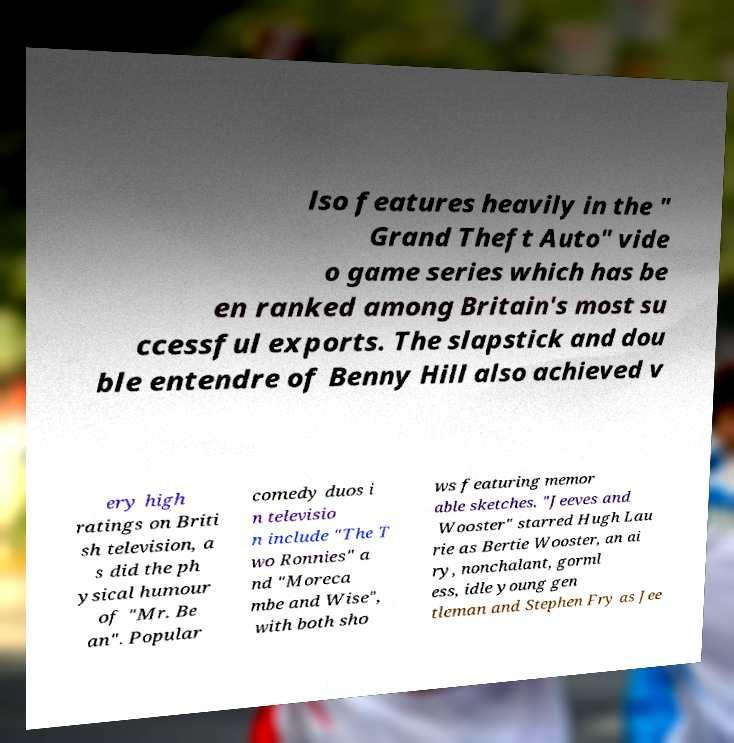For documentation purposes, I need the text within this image transcribed. Could you provide that? lso features heavily in the " Grand Theft Auto" vide o game series which has be en ranked among Britain's most su ccessful exports. The slapstick and dou ble entendre of Benny Hill also achieved v ery high ratings on Briti sh television, a s did the ph ysical humour of "Mr. Be an". Popular comedy duos i n televisio n include "The T wo Ronnies" a nd "Moreca mbe and Wise", with both sho ws featuring memor able sketches. "Jeeves and Wooster" starred Hugh Lau rie as Bertie Wooster, an ai ry, nonchalant, gorml ess, idle young gen tleman and Stephen Fry as Jee 